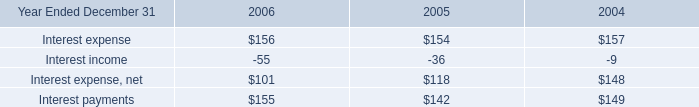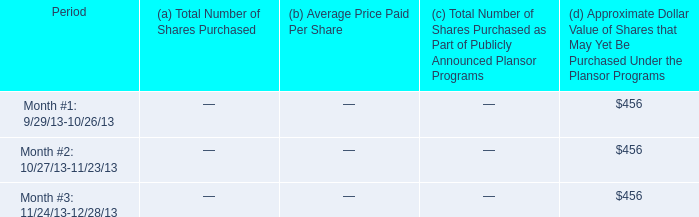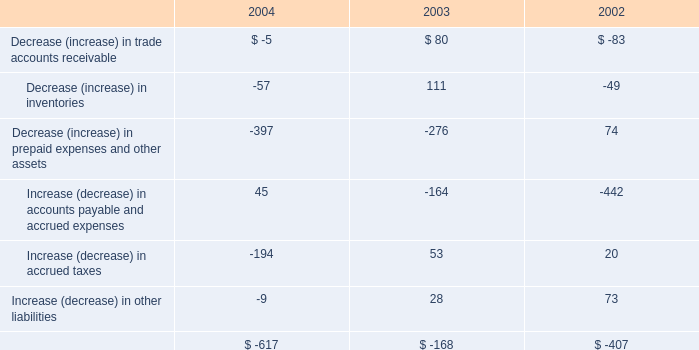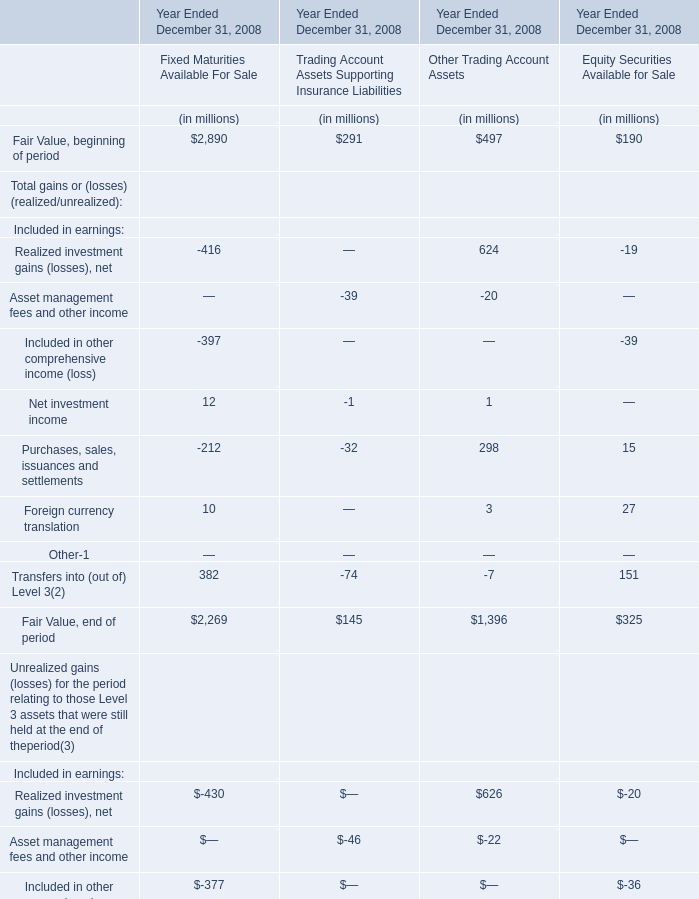what was the average share price in 2013? ( $ ) 
Computations: (544 / 9)
Answer: 60.44444. 